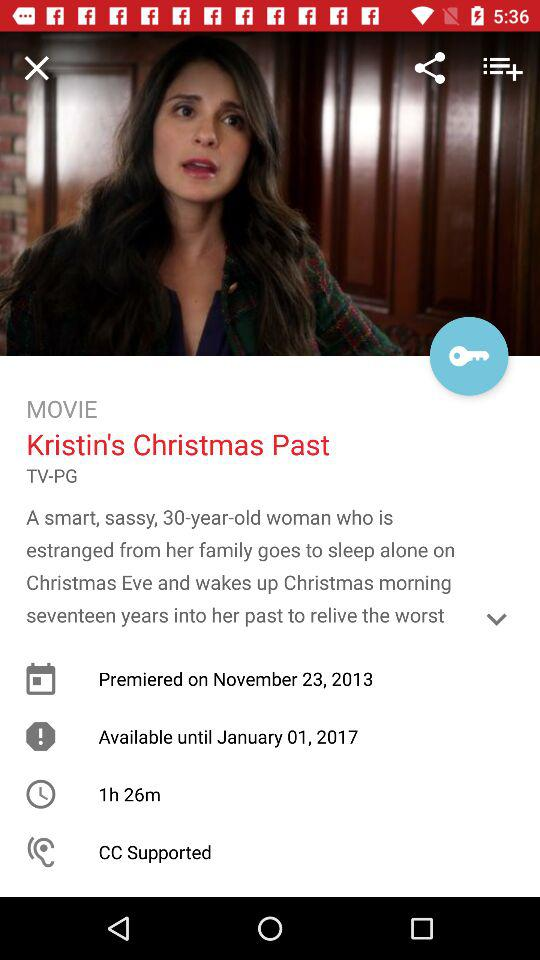What is the name of the movie? The name of the movie is "Kristin's Christmas Past". 